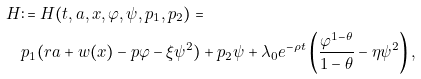<formula> <loc_0><loc_0><loc_500><loc_500>H & \colon = H ( t , a , x , \varphi , \psi , p _ { 1 } , p _ { 2 } ) = \\ & p _ { 1 } ( r a + w ( x ) - p \varphi - \xi \psi ^ { 2 } ) + p _ { 2 } \psi + \lambda _ { 0 } e ^ { - \rho t } \left ( \frac { \varphi ^ { 1 - \theta } } { 1 - \theta } - \eta \psi ^ { 2 } \right ) ,</formula> 